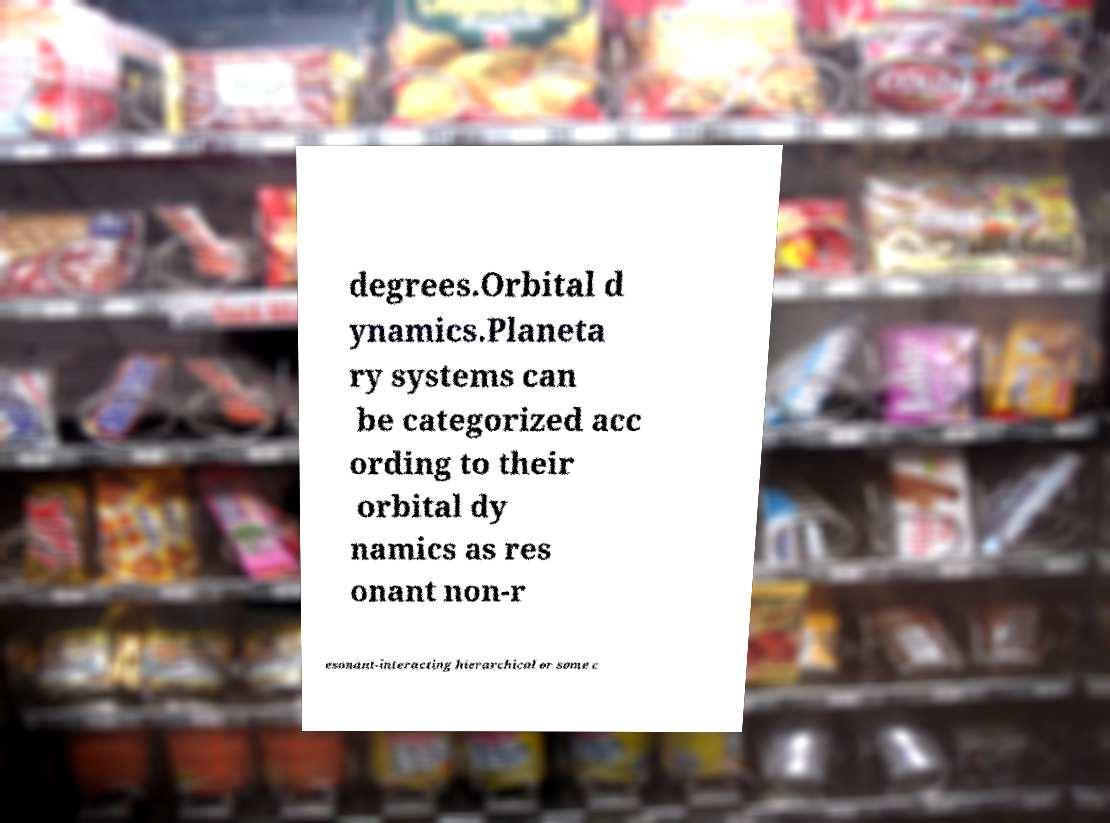There's text embedded in this image that I need extracted. Can you transcribe it verbatim? degrees.Orbital d ynamics.Planeta ry systems can be categorized acc ording to their orbital dy namics as res onant non-r esonant-interacting hierarchical or some c 